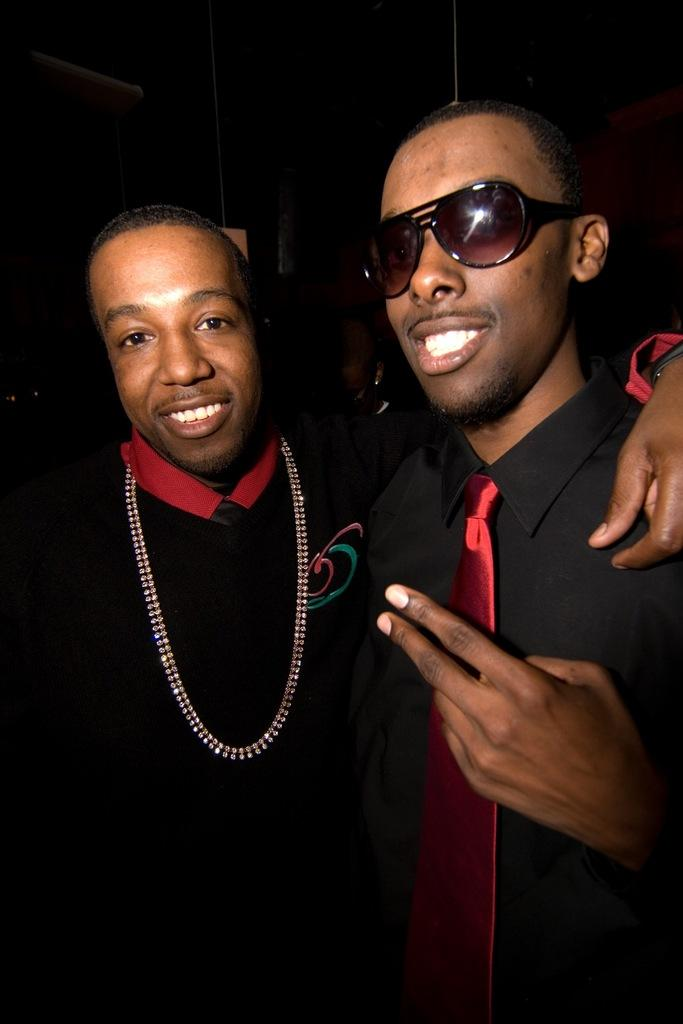How many people are in the image? There are two men in the image. What expressions do the men have? Both men are smiling in the image. What is one man wearing that is not typically worn by everyone? One man is wearing goggles. What can be observed about the lighting in the image? The background of the image is dark. What type of juice is being squeezed by the man in the image? There is no juice or squeezing activity present in the image. What discovery was made by the man wearing goggles in the image? There is no discovery or indication of a discovery in the image. 